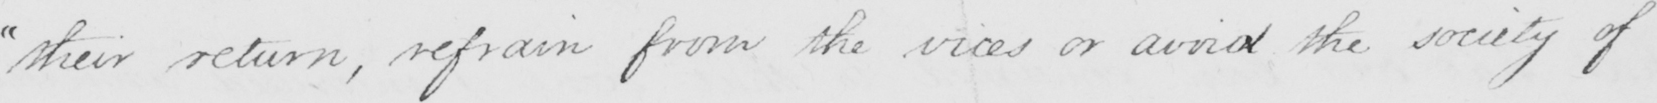What does this handwritten line say? " their return , refrain from the vices or avoid the society of 